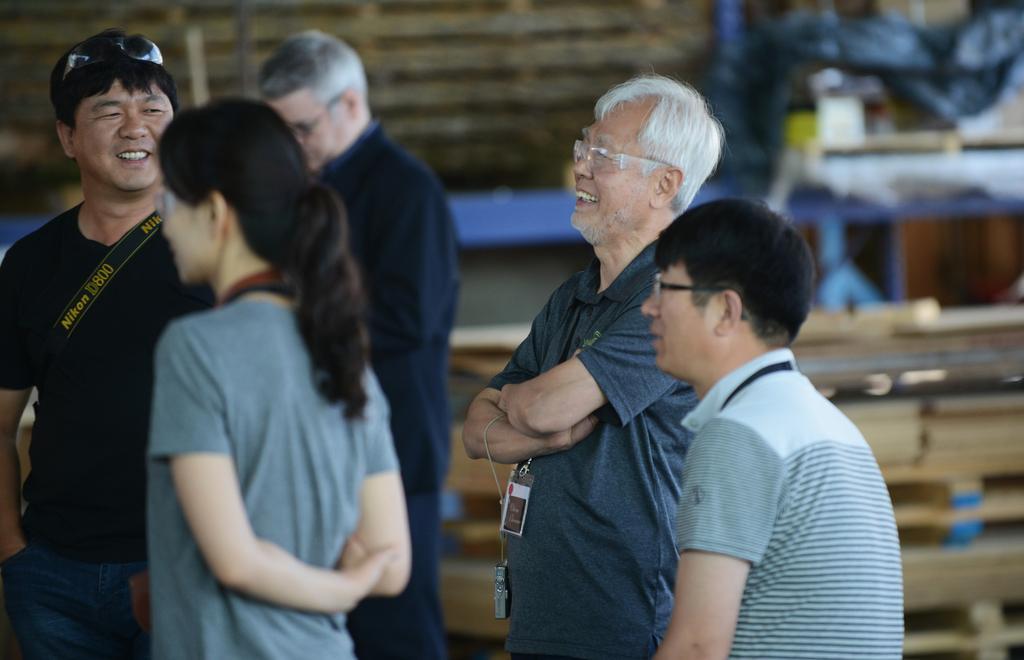Please provide a concise description of this image. In this image I can see few persons are standing on the ground and I can see one of them is sitting. In the background I can see few wooden objects and few other objects which are blurry. 